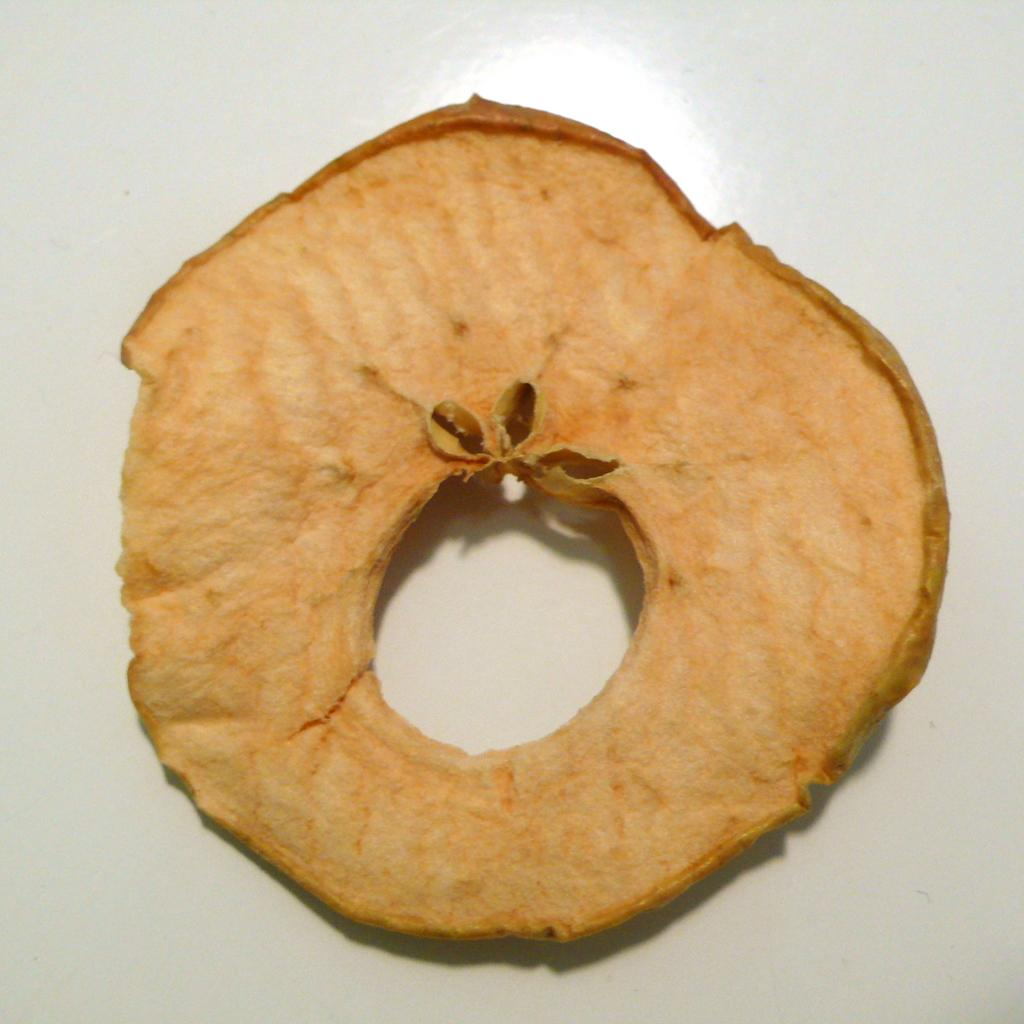What is depicted in the image? There is a slice of a fruit in the image. Can you describe the fruit slice in more detail? The fruit slice has seeds. What type of nail is being used by the farmer in the image? There is no farmer or nail present in the image; it only features a slice of a fruit with seeds. 